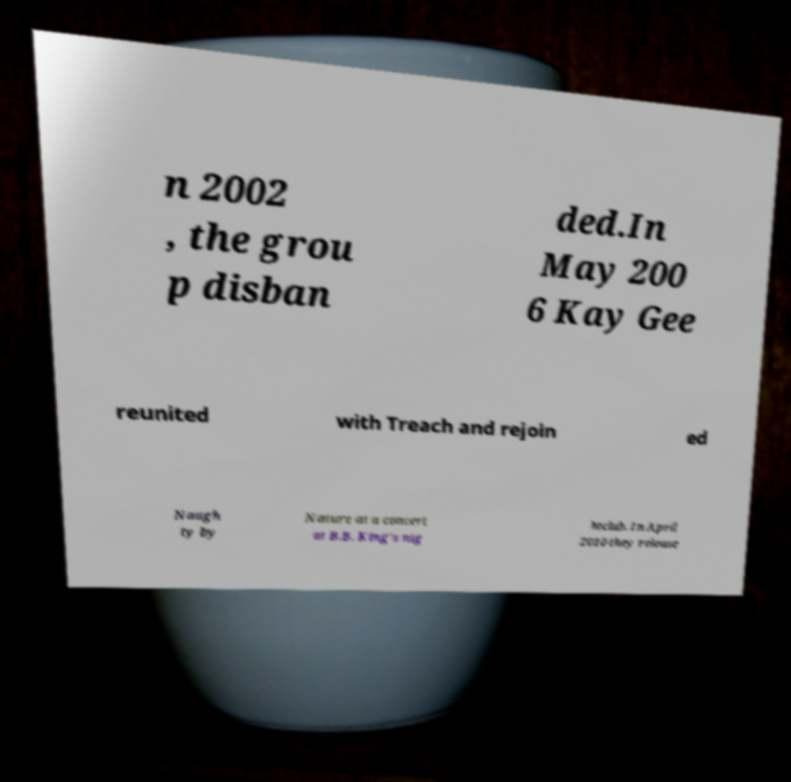Please read and relay the text visible in this image. What does it say? n 2002 , the grou p disban ded.In May 200 6 Kay Gee reunited with Treach and rejoin ed Naugh ty by Nature at a concert at B.B. King's nig htclub. In April 2010 they release 